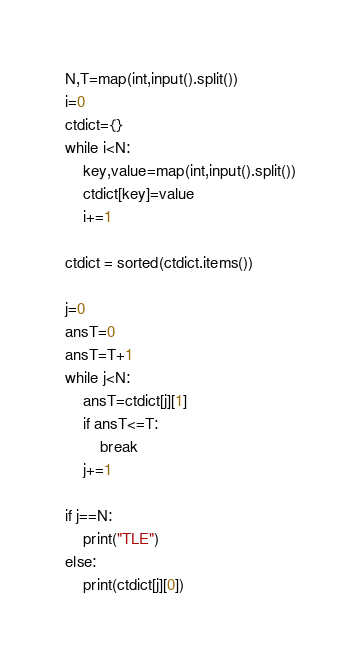Convert code to text. <code><loc_0><loc_0><loc_500><loc_500><_Python_>N,T=map(int,input().split())
i=0
ctdict={}
while i<N:
    key,value=map(int,input().split())
    ctdict[key]=value
    i+=1

ctdict = sorted(ctdict.items())

j=0
ansT=0
ansT=T+1
while j<N:
    ansT=ctdict[j][1]
    if ansT<=T:
        break
    j+=1

if j==N:
    print("TLE")
else:
    print(ctdict[j][0])

</code> 